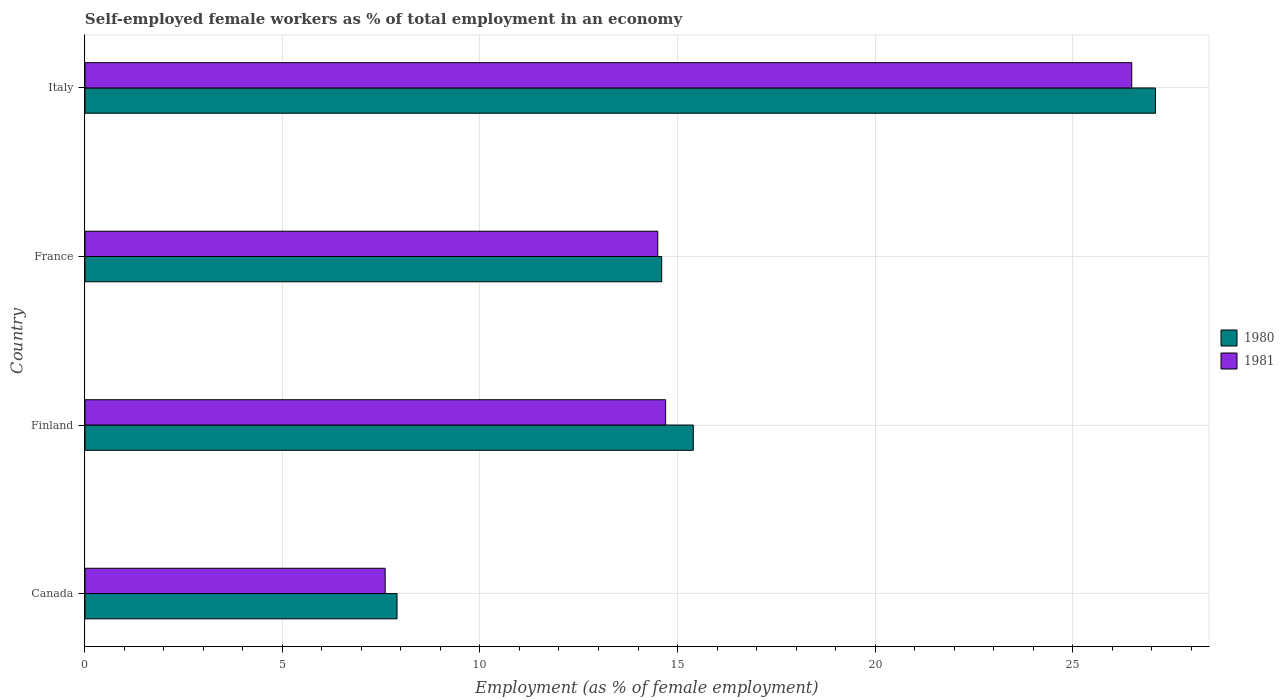How many different coloured bars are there?
Provide a succinct answer. 2. How many groups of bars are there?
Make the answer very short. 4. Are the number of bars per tick equal to the number of legend labels?
Provide a succinct answer. Yes. How many bars are there on the 3rd tick from the top?
Offer a very short reply. 2. What is the label of the 4th group of bars from the top?
Offer a very short reply. Canada. In how many cases, is the number of bars for a given country not equal to the number of legend labels?
Give a very brief answer. 0. What is the percentage of self-employed female workers in 1980 in France?
Provide a short and direct response. 14.6. Across all countries, what is the maximum percentage of self-employed female workers in 1980?
Give a very brief answer. 27.1. Across all countries, what is the minimum percentage of self-employed female workers in 1980?
Your answer should be compact. 7.9. In which country was the percentage of self-employed female workers in 1981 maximum?
Provide a succinct answer. Italy. What is the total percentage of self-employed female workers in 1980 in the graph?
Provide a short and direct response. 65. What is the difference between the percentage of self-employed female workers in 1981 in Canada and that in Italy?
Make the answer very short. -18.9. What is the difference between the percentage of self-employed female workers in 1980 in Canada and the percentage of self-employed female workers in 1981 in France?
Offer a very short reply. -6.6. What is the average percentage of self-employed female workers in 1980 per country?
Provide a short and direct response. 16.25. What is the difference between the percentage of self-employed female workers in 1980 and percentage of self-employed female workers in 1981 in Canada?
Offer a very short reply. 0.3. What is the ratio of the percentage of self-employed female workers in 1981 in France to that in Italy?
Your answer should be very brief. 0.55. Is the percentage of self-employed female workers in 1980 in France less than that in Italy?
Keep it short and to the point. Yes. What is the difference between the highest and the second highest percentage of self-employed female workers in 1980?
Provide a succinct answer. 11.7. What is the difference between the highest and the lowest percentage of self-employed female workers in 1980?
Make the answer very short. 19.2. What does the 1st bar from the bottom in France represents?
Ensure brevity in your answer.  1980. What is the difference between two consecutive major ticks on the X-axis?
Offer a terse response. 5. Does the graph contain any zero values?
Provide a short and direct response. No. Where does the legend appear in the graph?
Ensure brevity in your answer.  Center right. How many legend labels are there?
Ensure brevity in your answer.  2. What is the title of the graph?
Your answer should be very brief. Self-employed female workers as % of total employment in an economy. What is the label or title of the X-axis?
Offer a very short reply. Employment (as % of female employment). What is the label or title of the Y-axis?
Your answer should be compact. Country. What is the Employment (as % of female employment) in 1980 in Canada?
Your answer should be very brief. 7.9. What is the Employment (as % of female employment) in 1981 in Canada?
Ensure brevity in your answer.  7.6. What is the Employment (as % of female employment) in 1980 in Finland?
Offer a terse response. 15.4. What is the Employment (as % of female employment) in 1981 in Finland?
Offer a terse response. 14.7. What is the Employment (as % of female employment) in 1980 in France?
Your response must be concise. 14.6. What is the Employment (as % of female employment) in 1980 in Italy?
Keep it short and to the point. 27.1. Across all countries, what is the maximum Employment (as % of female employment) in 1980?
Your answer should be compact. 27.1. Across all countries, what is the minimum Employment (as % of female employment) in 1980?
Keep it short and to the point. 7.9. Across all countries, what is the minimum Employment (as % of female employment) in 1981?
Make the answer very short. 7.6. What is the total Employment (as % of female employment) of 1981 in the graph?
Keep it short and to the point. 63.3. What is the difference between the Employment (as % of female employment) of 1980 in Canada and that in Finland?
Ensure brevity in your answer.  -7.5. What is the difference between the Employment (as % of female employment) of 1980 in Canada and that in Italy?
Ensure brevity in your answer.  -19.2. What is the difference between the Employment (as % of female employment) in 1981 in Canada and that in Italy?
Your answer should be very brief. -18.9. What is the difference between the Employment (as % of female employment) in 1981 in Finland and that in Italy?
Provide a short and direct response. -11.8. What is the difference between the Employment (as % of female employment) of 1980 in Canada and the Employment (as % of female employment) of 1981 in Finland?
Provide a short and direct response. -6.8. What is the difference between the Employment (as % of female employment) in 1980 in Canada and the Employment (as % of female employment) in 1981 in Italy?
Your response must be concise. -18.6. What is the difference between the Employment (as % of female employment) in 1980 in Finland and the Employment (as % of female employment) in 1981 in France?
Ensure brevity in your answer.  0.9. What is the average Employment (as % of female employment) of 1980 per country?
Offer a very short reply. 16.25. What is the average Employment (as % of female employment) of 1981 per country?
Make the answer very short. 15.82. What is the difference between the Employment (as % of female employment) in 1980 and Employment (as % of female employment) in 1981 in Canada?
Ensure brevity in your answer.  0.3. What is the ratio of the Employment (as % of female employment) in 1980 in Canada to that in Finland?
Ensure brevity in your answer.  0.51. What is the ratio of the Employment (as % of female employment) in 1981 in Canada to that in Finland?
Give a very brief answer. 0.52. What is the ratio of the Employment (as % of female employment) in 1980 in Canada to that in France?
Provide a short and direct response. 0.54. What is the ratio of the Employment (as % of female employment) of 1981 in Canada to that in France?
Give a very brief answer. 0.52. What is the ratio of the Employment (as % of female employment) of 1980 in Canada to that in Italy?
Your answer should be compact. 0.29. What is the ratio of the Employment (as % of female employment) in 1981 in Canada to that in Italy?
Your answer should be very brief. 0.29. What is the ratio of the Employment (as % of female employment) in 1980 in Finland to that in France?
Offer a terse response. 1.05. What is the ratio of the Employment (as % of female employment) of 1981 in Finland to that in France?
Keep it short and to the point. 1.01. What is the ratio of the Employment (as % of female employment) of 1980 in Finland to that in Italy?
Give a very brief answer. 0.57. What is the ratio of the Employment (as % of female employment) in 1981 in Finland to that in Italy?
Keep it short and to the point. 0.55. What is the ratio of the Employment (as % of female employment) in 1980 in France to that in Italy?
Your answer should be very brief. 0.54. What is the ratio of the Employment (as % of female employment) in 1981 in France to that in Italy?
Provide a short and direct response. 0.55. What is the difference between the highest and the lowest Employment (as % of female employment) in 1980?
Keep it short and to the point. 19.2. What is the difference between the highest and the lowest Employment (as % of female employment) of 1981?
Keep it short and to the point. 18.9. 